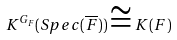<formula> <loc_0><loc_0><loc_500><loc_500>K ^ { G _ { F } } ( S p e c ( \overline { F } ) ) \cong K ( F )</formula> 